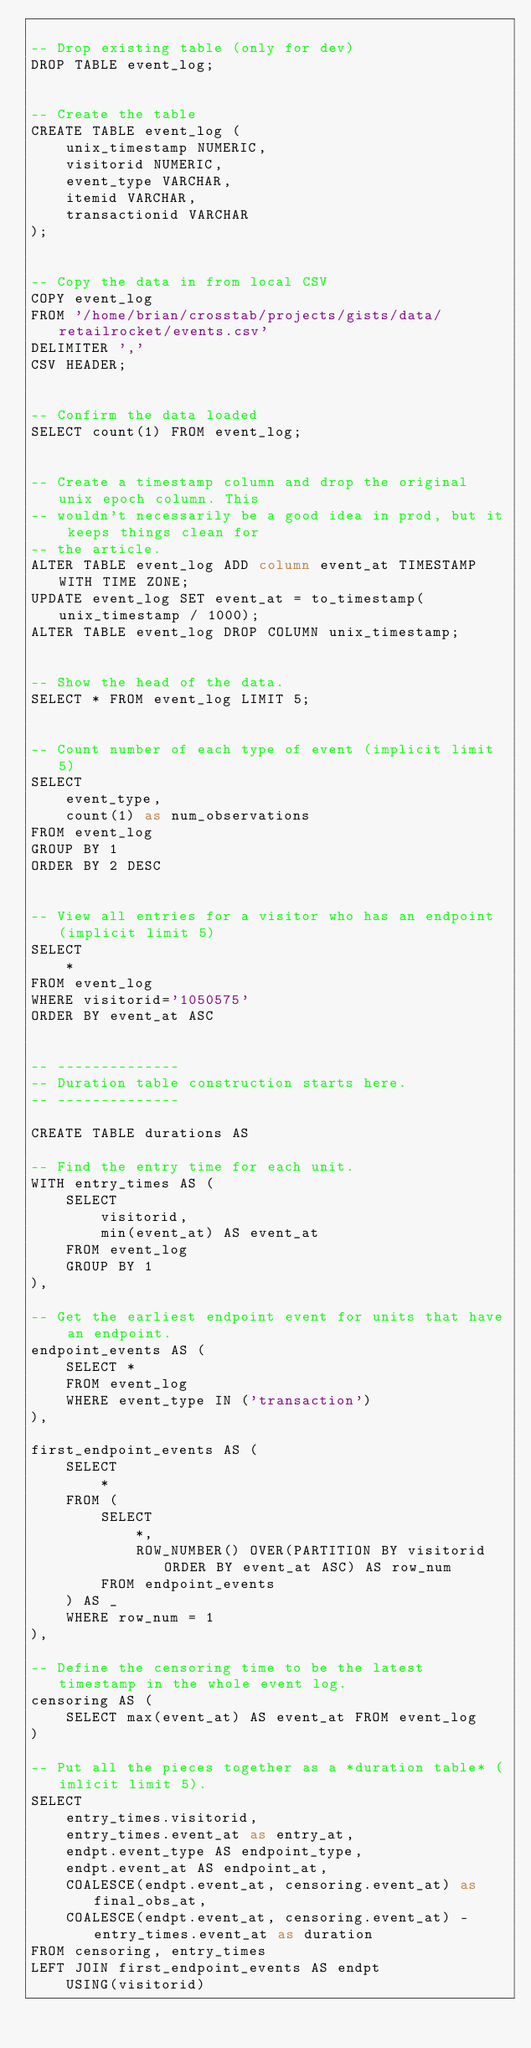<code> <loc_0><loc_0><loc_500><loc_500><_SQL_>
-- Drop existing table (only for dev)
DROP TABLE event_log;


-- Create the table
CREATE TABLE event_log (
    unix_timestamp NUMERIC,
    visitorid NUMERIC, 
    event_type VARCHAR, 
    itemid VARCHAR, 
    transactionid VARCHAR
);


-- Copy the data in from local CSV
COPY event_log 
FROM '/home/brian/crosstab/projects/gists/data/retailrocket/events.csv' 
DELIMITER ',' 
CSV HEADER;


-- Confirm the data loaded
SELECT count(1) FROM event_log;


-- Create a timestamp column and drop the original unix epoch column. This
-- wouldn't necessarily be a good idea in prod, but it keeps things clean for
-- the article.
ALTER TABLE event_log ADD column event_at TIMESTAMP WITH TIME ZONE;
UPDATE event_log SET event_at = to_timestamp(unix_timestamp / 1000);
ALTER TABLE event_log DROP COLUMN unix_timestamp;


-- Show the head of the data.
SELECT * FROM event_log LIMIT 5;


-- Count number of each type of event (implicit limit 5)
SELECT
    event_type,
    count(1) as num_observations
FROM event_log
GROUP BY 1
ORDER BY 2 DESC


-- View all entries for a visitor who has an endpoint (implicit limit 5)
SELECT
    *
FROM event_log 
WHERE visitorid='1050575' 
ORDER BY event_at ASC


-- --------------
-- Duration table construction starts here.
-- --------------

CREATE TABLE durations AS 

-- Find the entry time for each unit.
WITH entry_times AS (
    SELECT
        visitorid,
        min(event_at) AS event_at
    FROM event_log
    GROUP BY 1
),

-- Get the earliest endpoint event for units that have an endpoint.
endpoint_events AS (
    SELECT *
    FROM event_log
    WHERE event_type IN ('transaction')
),

first_endpoint_events AS (
    SELECT 
        *
    FROM (
        SELECT
            *,
            ROW_NUMBER() OVER(PARTITION BY visitorid ORDER BY event_at ASC) AS row_num
        FROM endpoint_events
    ) AS _
    WHERE row_num = 1
),

-- Define the censoring time to be the latest timestamp in the whole event log.
censoring AS (
    SELECT max(event_at) AS event_at FROM event_log
)

-- Put all the pieces together as a *duration table* (imlicit limit 5).
SELECT 
    entry_times.visitorid,
    entry_times.event_at as entry_at,
    endpt.event_type AS endpoint_type,
    endpt.event_at AS endpoint_at,
    COALESCE(endpt.event_at, censoring.event_at) as final_obs_at,
    COALESCE(endpt.event_at, censoring.event_at) - entry_times.event_at as duration
FROM censoring, entry_times
LEFT JOIN first_endpoint_events AS endpt
    USING(visitorid)

</code> 